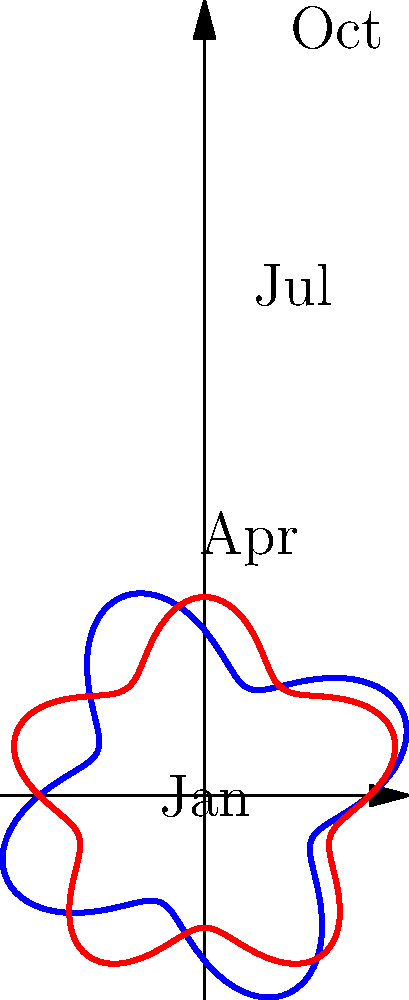The spiral plot above shows rally attendance for two candidates over a year. The distance from the center represents the number of attendees, while the angle represents the time of year. Based on this visualization, which statement is most accurate regarding the candidates' rally performances? To analyze the spiral plot and determine the most accurate statement about the candidates' rally performances, let's break it down step-by-step:

1. Interpret the plot:
   - The blue line represents Candidate A's rally attendance.
   - The red line represents Candidate B's rally attendance.
   - The distance from the center indicates the number of attendees.
   - The angle represents the time of year (Jan, Apr, Jul, Oct).

2. Observe the patterns:
   - Candidate A (blue) has four peaks throughout the year.
   - Candidate B (red) has five peaks throughout the year.
   - Candidate A's peaks are generally higher than Candidate B's.

3. Analyze the fluctuations:
   - Candidate A's attendance varies more dramatically between peaks and troughs.
   - Candidate B's attendance is more consistent, with smaller variations.

4. Compare overall performance:
   - Candidate A's line generally extends further from the center, indicating larger rallies on average.
   - Candidate B's line stays closer to the center, suggesting smaller but more frequent rallies.

5. Consider timing:
   - Candidate A's peaks align roughly with the four seasons.
   - Candidate B's peaks occur more frequently, about every 2.4 months.

Based on these observations, the most accurate statement would be that Candidate A tends to have larger but less frequent rallies, while Candidate B holds smaller but more consistent and frequent rallies throughout the year.
Answer: Candidate A has larger but less frequent rallies; Candidate B has smaller but more consistent and frequent rallies. 